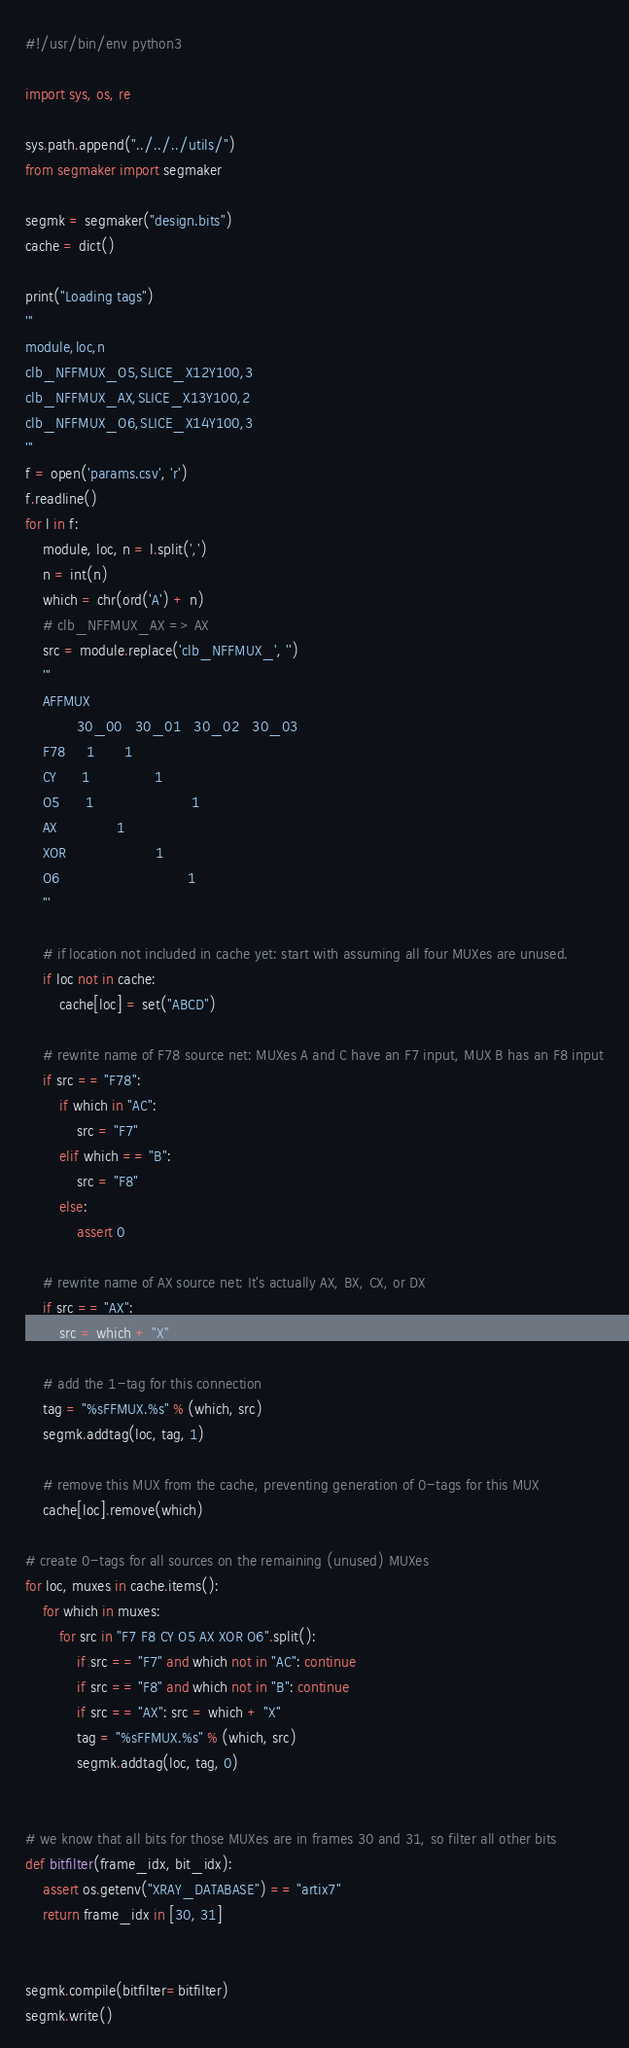<code> <loc_0><loc_0><loc_500><loc_500><_Python_>#!/usr/bin/env python3

import sys, os, re

sys.path.append("../../../utils/")
from segmaker import segmaker

segmk = segmaker("design.bits")
cache = dict()

print("Loading tags")
'''
module,loc,n
clb_NFFMUX_O5,SLICE_X12Y100,3
clb_NFFMUX_AX,SLICE_X13Y100,2
clb_NFFMUX_O6,SLICE_X14Y100,3
'''
f = open('params.csv', 'r')
f.readline()
for l in f:
    module, loc, n = l.split(',')
    n = int(n)
    which = chr(ord('A') + n)
    # clb_NFFMUX_AX => AX
    src = module.replace('clb_NFFMUX_', '')
    '''
    AFFMUX
            30_00   30_01   30_02   30_03
    F78     1       1
    CY      1               1
    O5      1                       1
    AX              1
    XOR                     1
    O6                              1
    '''

    # if location not included in cache yet: start with assuming all four MUXes are unused.
    if loc not in cache:
        cache[loc] = set("ABCD")

    # rewrite name of F78 source net: MUXes A and C have an F7 input, MUX B has an F8 input
    if src == "F78":
        if which in "AC":
            src = "F7"
        elif which == "B":
            src = "F8"
        else:
            assert 0

    # rewrite name of AX source net: It's actually AX, BX, CX, or DX
    if src == "AX":
        src = which + "X"

    # add the 1-tag for this connection
    tag = "%sFFMUX.%s" % (which, src)
    segmk.addtag(loc, tag, 1)

    # remove this MUX from the cache, preventing generation of 0-tags for this MUX
    cache[loc].remove(which)

# create 0-tags for all sources on the remaining (unused) MUXes
for loc, muxes in cache.items():
    for which in muxes:
        for src in "F7 F8 CY O5 AX XOR O6".split():
            if src == "F7" and which not in "AC": continue
            if src == "F8" and which not in "B": continue
            if src == "AX": src = which + "X"
            tag = "%sFFMUX.%s" % (which, src)
            segmk.addtag(loc, tag, 0)


# we know that all bits for those MUXes are in frames 30 and 31, so filter all other bits
def bitfilter(frame_idx, bit_idx):
    assert os.getenv("XRAY_DATABASE") == "artix7"
    return frame_idx in [30, 31]


segmk.compile(bitfilter=bitfilter)
segmk.write()
</code> 